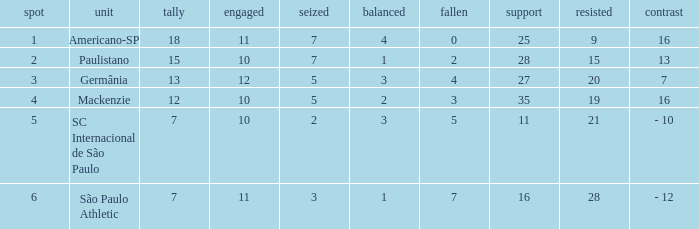Name the points for paulistano 15.0. 